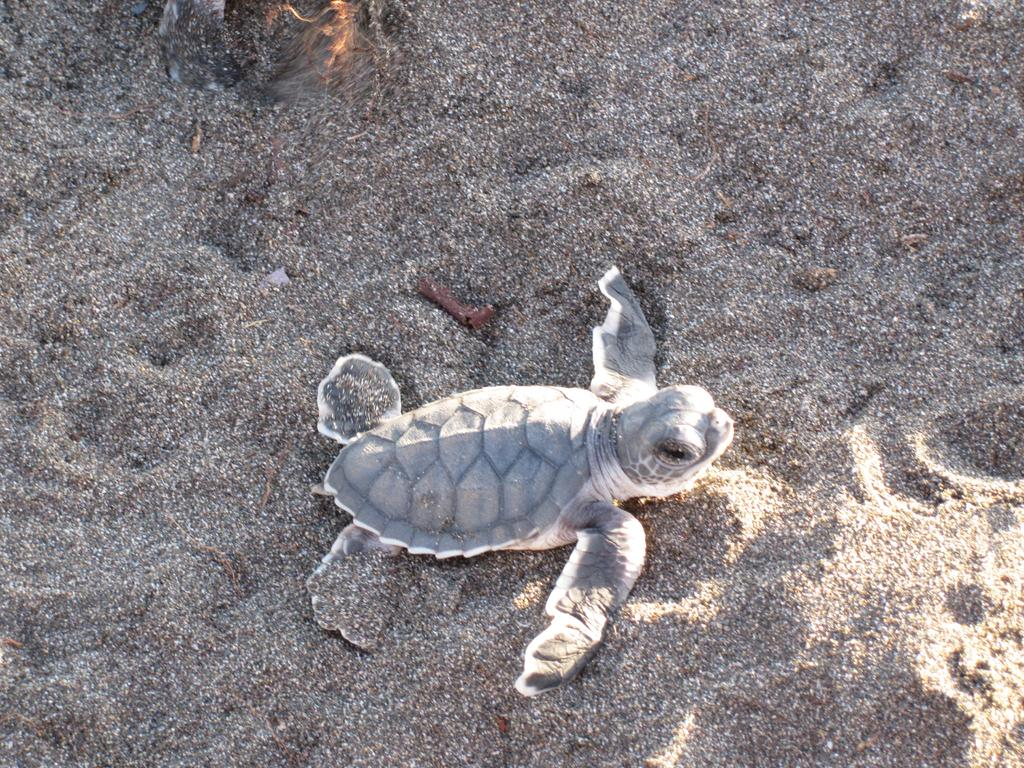What animal is present in the image? There is a turtle in the image. Where is the turtle located? The turtle is on the ground. What side of the turtle is feeling sad in the image? There is no indication in the image that the turtle is feeling sad or that it has a specific side that is feeling sad. 